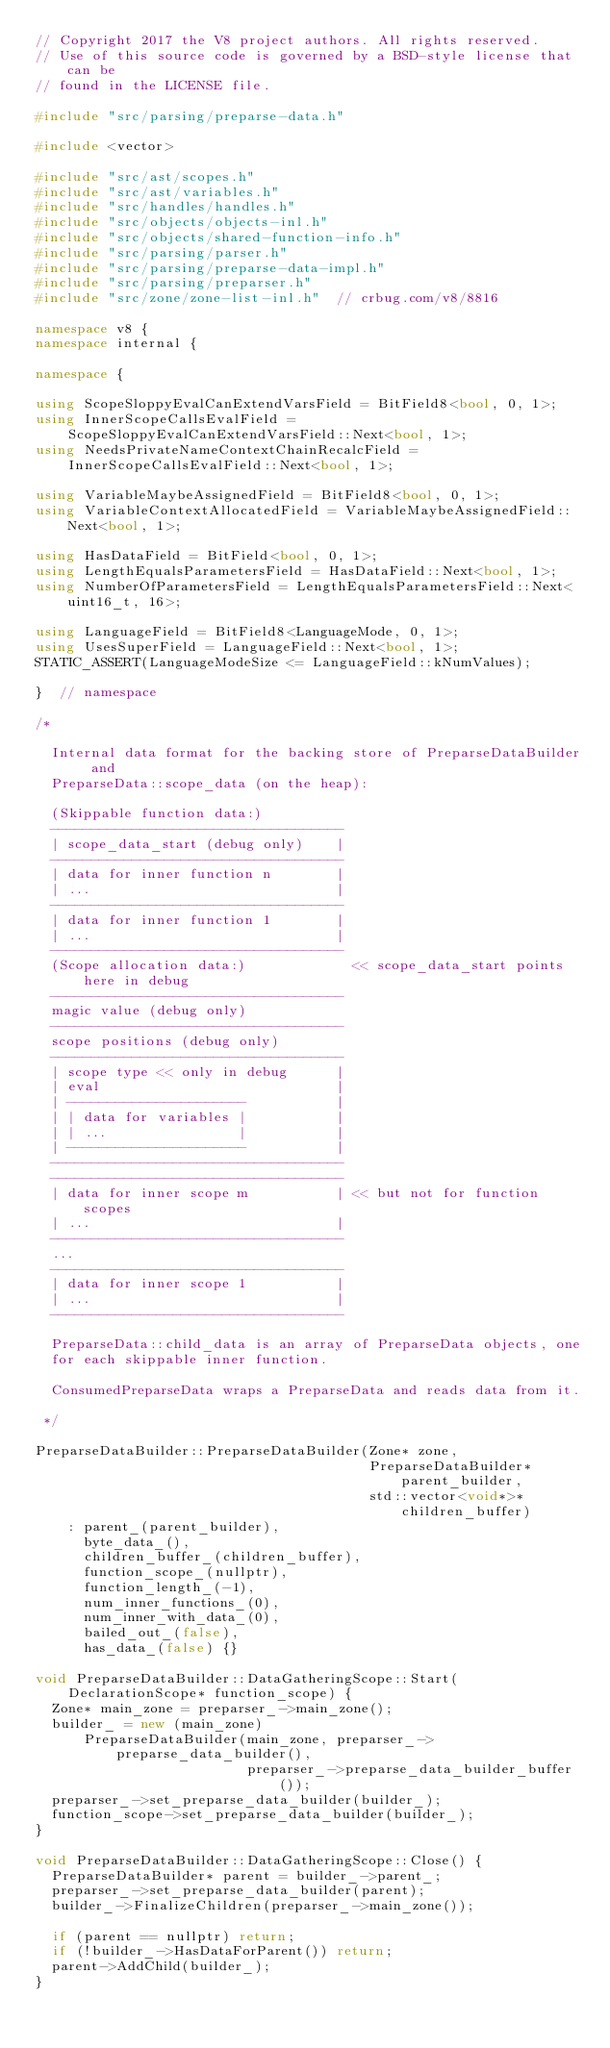<code> <loc_0><loc_0><loc_500><loc_500><_C++_>// Copyright 2017 the V8 project authors. All rights reserved.
// Use of this source code is governed by a BSD-style license that can be
// found in the LICENSE file.

#include "src/parsing/preparse-data.h"

#include <vector>

#include "src/ast/scopes.h"
#include "src/ast/variables.h"
#include "src/handles/handles.h"
#include "src/objects/objects-inl.h"
#include "src/objects/shared-function-info.h"
#include "src/parsing/parser.h"
#include "src/parsing/preparse-data-impl.h"
#include "src/parsing/preparser.h"
#include "src/zone/zone-list-inl.h"  // crbug.com/v8/8816

namespace v8 {
namespace internal {

namespace {

using ScopeSloppyEvalCanExtendVarsField = BitField8<bool, 0, 1>;
using InnerScopeCallsEvalField =
    ScopeSloppyEvalCanExtendVarsField::Next<bool, 1>;
using NeedsPrivateNameContextChainRecalcField =
    InnerScopeCallsEvalField::Next<bool, 1>;

using VariableMaybeAssignedField = BitField8<bool, 0, 1>;
using VariableContextAllocatedField = VariableMaybeAssignedField::Next<bool, 1>;

using HasDataField = BitField<bool, 0, 1>;
using LengthEqualsParametersField = HasDataField::Next<bool, 1>;
using NumberOfParametersField = LengthEqualsParametersField::Next<uint16_t, 16>;

using LanguageField = BitField8<LanguageMode, 0, 1>;
using UsesSuperField = LanguageField::Next<bool, 1>;
STATIC_ASSERT(LanguageModeSize <= LanguageField::kNumValues);

}  // namespace

/*

  Internal data format for the backing store of PreparseDataBuilder and
  PreparseData::scope_data (on the heap):

  (Skippable function data:)
  ------------------------------------
  | scope_data_start (debug only)    |
  ------------------------------------
  | data for inner function n        |
  | ...                              |
  ------------------------------------
  | data for inner function 1        |
  | ...                              |
  ------------------------------------
  (Scope allocation data:)             << scope_data_start points here in debug
  ------------------------------------
  magic value (debug only)
  ------------------------------------
  scope positions (debug only)
  ------------------------------------
  | scope type << only in debug      |
  | eval                             |
  | ----------------------           |
  | | data for variables |           |
  | | ...                |           |
  | ----------------------           |
  ------------------------------------
  ------------------------------------
  | data for inner scope m           | << but not for function scopes
  | ...                              |
  ------------------------------------
  ...
  ------------------------------------
  | data for inner scope 1           |
  | ...                              |
  ------------------------------------

  PreparseData::child_data is an array of PreparseData objects, one
  for each skippable inner function.

  ConsumedPreparseData wraps a PreparseData and reads data from it.

 */

PreparseDataBuilder::PreparseDataBuilder(Zone* zone,
                                         PreparseDataBuilder* parent_builder,
                                         std::vector<void*>* children_buffer)
    : parent_(parent_builder),
      byte_data_(),
      children_buffer_(children_buffer),
      function_scope_(nullptr),
      function_length_(-1),
      num_inner_functions_(0),
      num_inner_with_data_(0),
      bailed_out_(false),
      has_data_(false) {}

void PreparseDataBuilder::DataGatheringScope::Start(
    DeclarationScope* function_scope) {
  Zone* main_zone = preparser_->main_zone();
  builder_ = new (main_zone)
      PreparseDataBuilder(main_zone, preparser_->preparse_data_builder(),
                          preparser_->preparse_data_builder_buffer());
  preparser_->set_preparse_data_builder(builder_);
  function_scope->set_preparse_data_builder(builder_);
}

void PreparseDataBuilder::DataGatheringScope::Close() {
  PreparseDataBuilder* parent = builder_->parent_;
  preparser_->set_preparse_data_builder(parent);
  builder_->FinalizeChildren(preparser_->main_zone());

  if (parent == nullptr) return;
  if (!builder_->HasDataForParent()) return;
  parent->AddChild(builder_);
}
</code> 